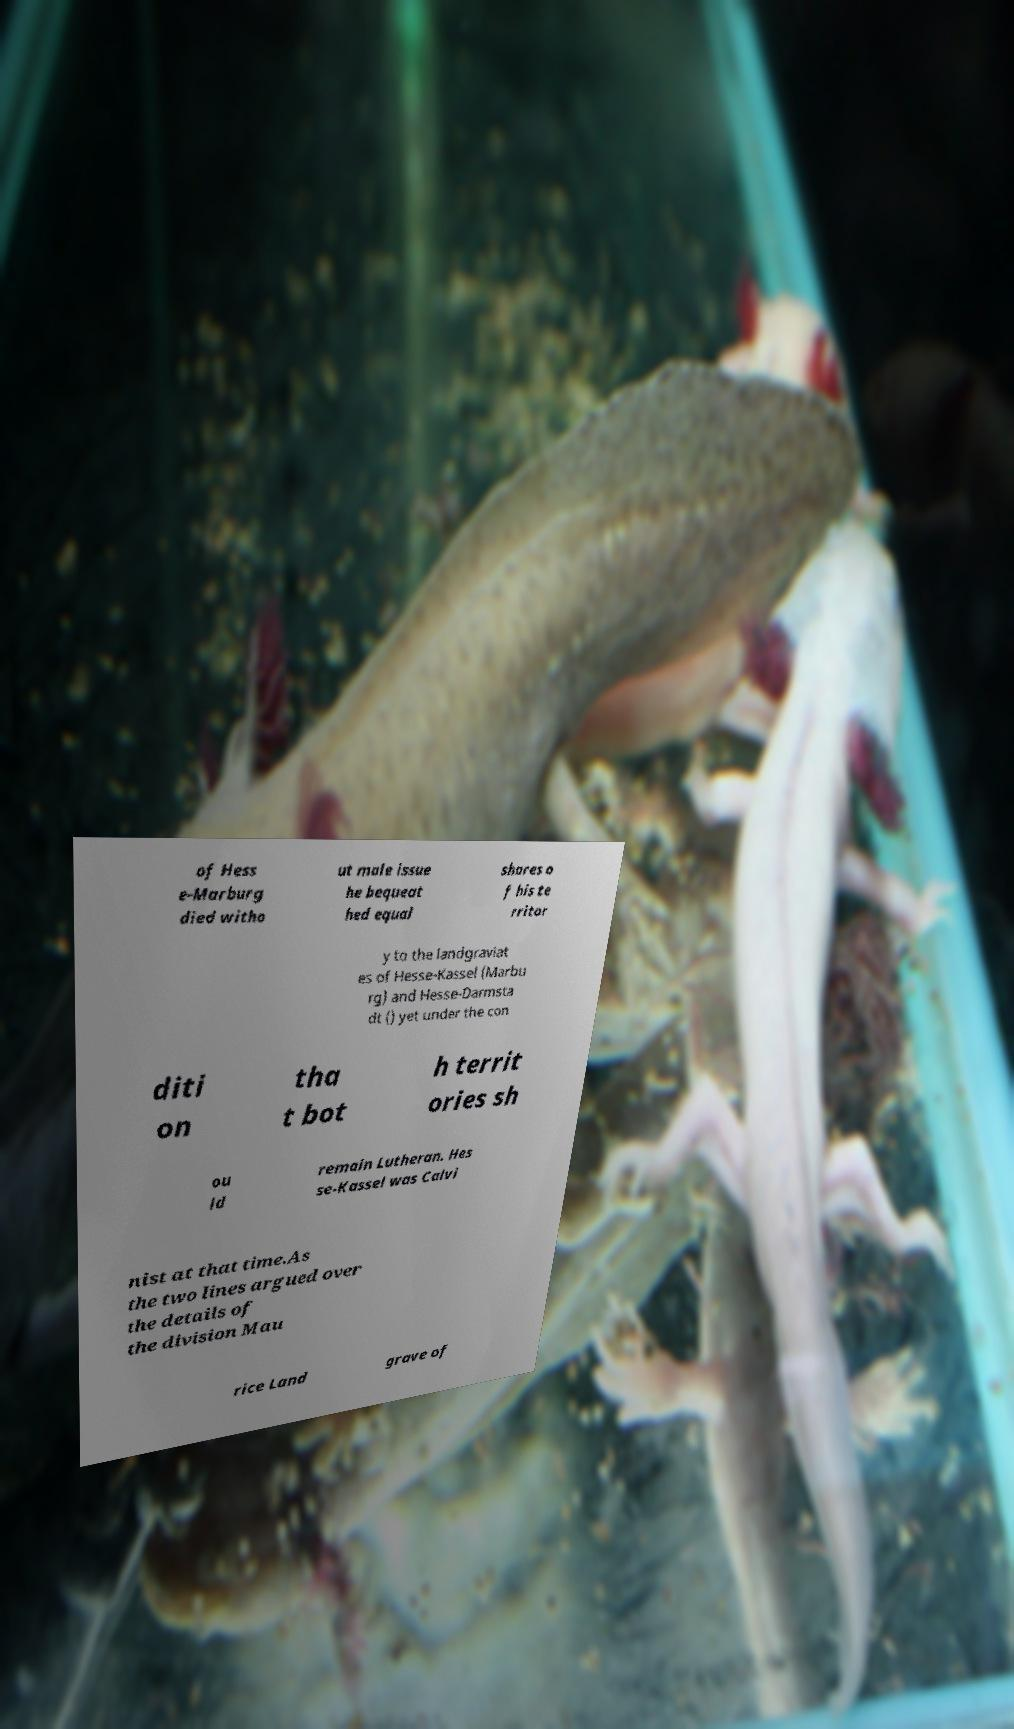For documentation purposes, I need the text within this image transcribed. Could you provide that? of Hess e-Marburg died witho ut male issue he bequeat hed equal shares o f his te rritor y to the landgraviat es of Hesse-Kassel (Marbu rg) and Hesse-Darmsta dt () yet under the con diti on tha t bot h territ ories sh ou ld remain Lutheran. Hes se-Kassel was Calvi nist at that time.As the two lines argued over the details of the division Mau rice Land grave of 